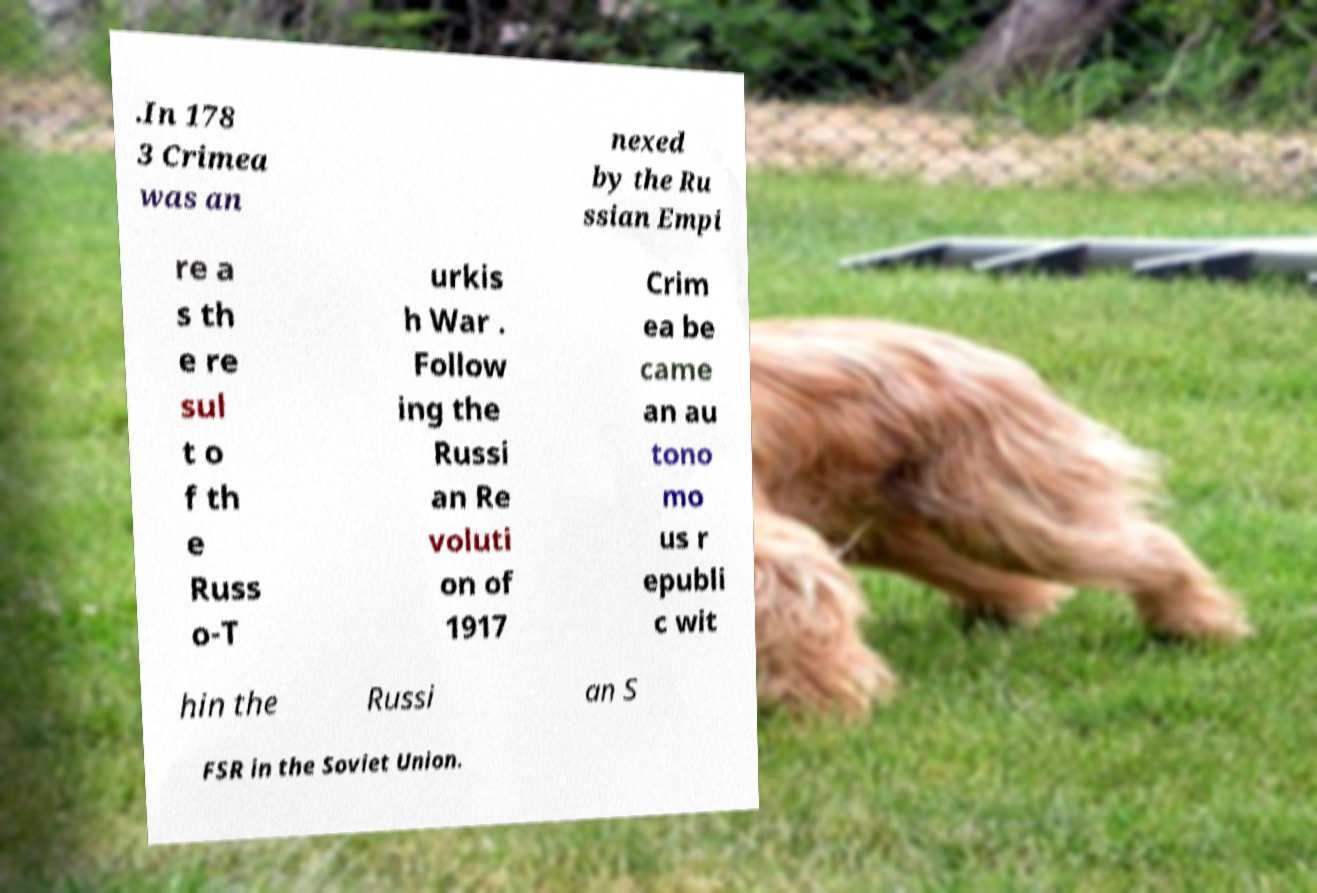Can you read and provide the text displayed in the image?This photo seems to have some interesting text. Can you extract and type it out for me? .In 178 3 Crimea was an nexed by the Ru ssian Empi re a s th e re sul t o f th e Russ o-T urkis h War . Follow ing the Russi an Re voluti on of 1917 Crim ea be came an au tono mo us r epubli c wit hin the Russi an S FSR in the Soviet Union. 